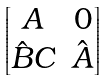<formula> <loc_0><loc_0><loc_500><loc_500>\begin{bmatrix} A & 0 \\ \hat { B } C & \hat { A } \end{bmatrix}</formula> 